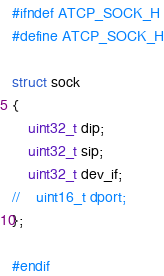<code> <loc_0><loc_0><loc_500><loc_500><_C_>#ifndef ATCP_SOCK_H
#define ATCP_SOCK_H

struct sock
{
    uint32_t dip;
    uint32_t sip;
    uint32_t dev_if;
//    uint16_t dport;
};

#endif
</code> 